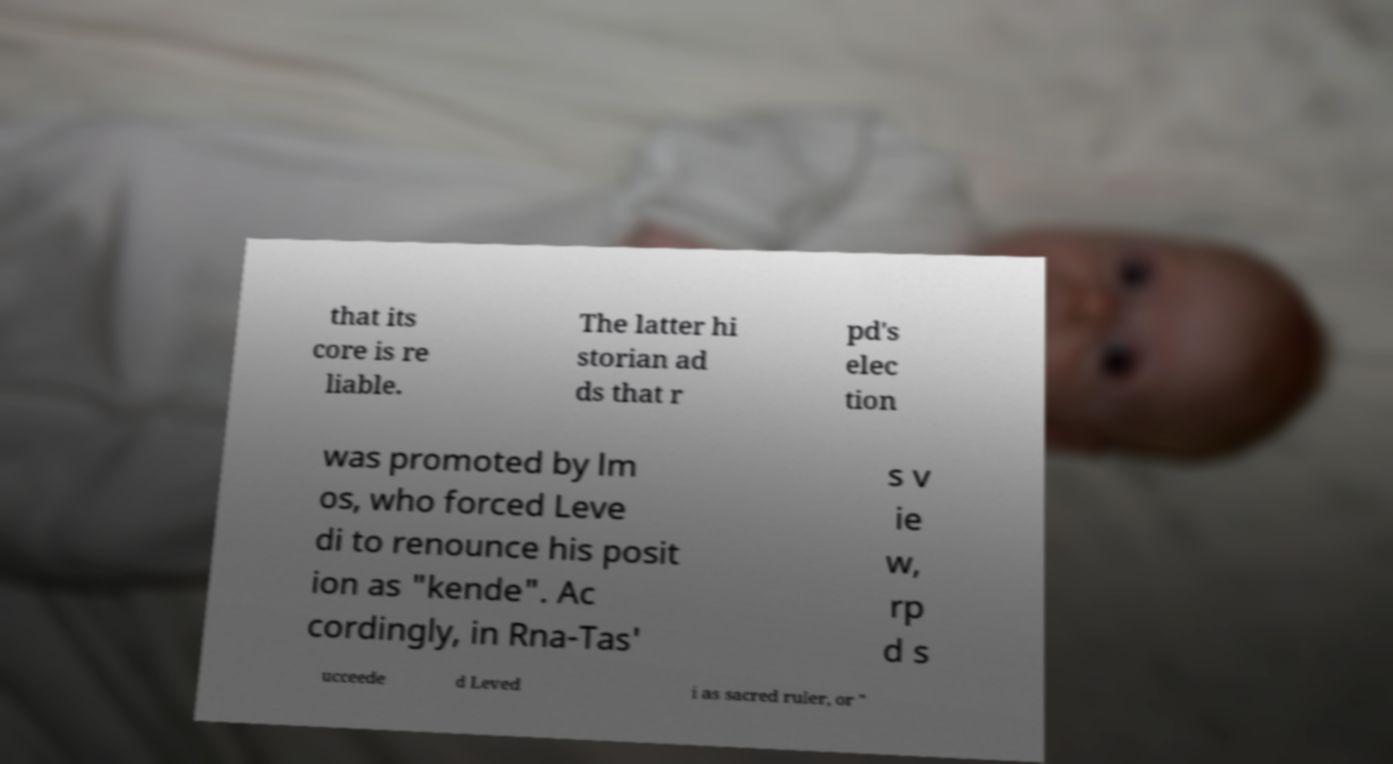I need the written content from this picture converted into text. Can you do that? that its core is re liable. The latter hi storian ad ds that r pd's elec tion was promoted by lm os, who forced Leve di to renounce his posit ion as "kende". Ac cordingly, in Rna-Tas' s v ie w, rp d s ucceede d Leved i as sacred ruler, or " 